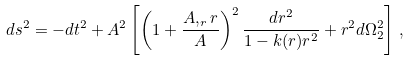Convert formula to latex. <formula><loc_0><loc_0><loc_500><loc_500>d s ^ { 2 } = - d t ^ { 2 } + A ^ { 2 } \left [ \left ( 1 + \frac { A , _ { r } r } { A } \right ) ^ { 2 } \frac { d r ^ { 2 } } { 1 - k ( r ) r ^ { 2 } } + r ^ { 2 } d \Omega _ { 2 } ^ { 2 } \right ] \, ,</formula> 